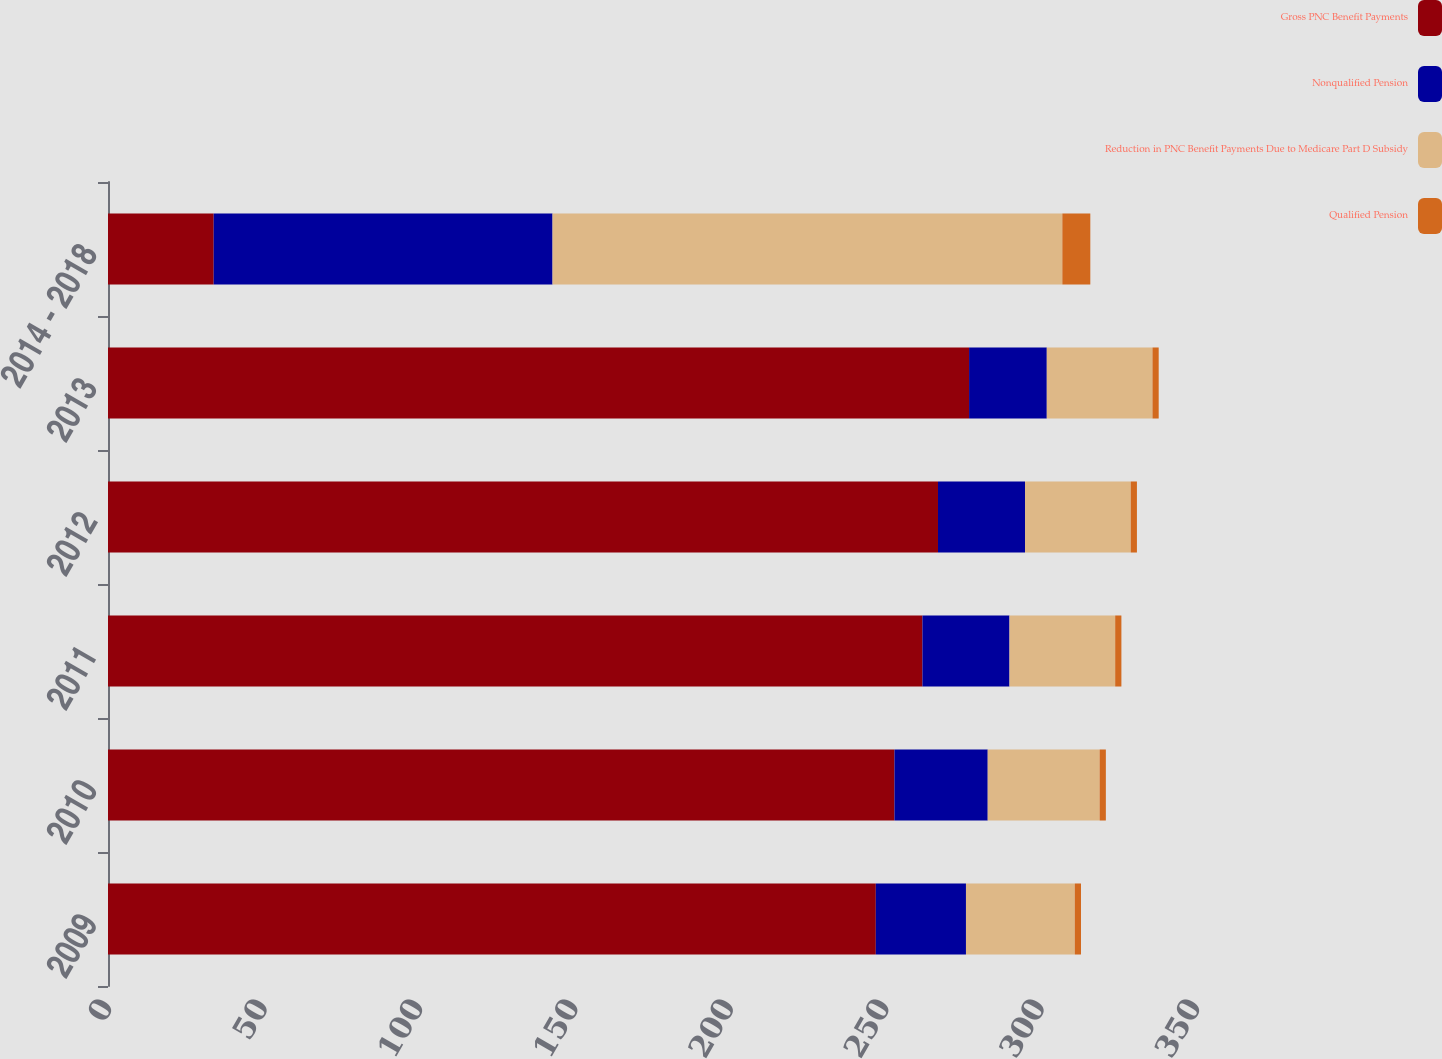Convert chart to OTSL. <chart><loc_0><loc_0><loc_500><loc_500><stacked_bar_chart><ecel><fcel>2009<fcel>2010<fcel>2011<fcel>2012<fcel>2013<fcel>2014 - 2018<nl><fcel>Gross PNC Benefit Payments<fcel>247<fcel>253<fcel>262<fcel>267<fcel>277<fcel>34<nl><fcel>Nonqualified Pension<fcel>29<fcel>30<fcel>28<fcel>28<fcel>25<fcel>109<nl><fcel>Reduction in PNC Benefit Payments Due to Medicare Part D Subsidy<fcel>35<fcel>36<fcel>34<fcel>34<fcel>34<fcel>164<nl><fcel>Qualified Pension<fcel>2<fcel>2<fcel>2<fcel>2<fcel>2<fcel>9<nl></chart> 